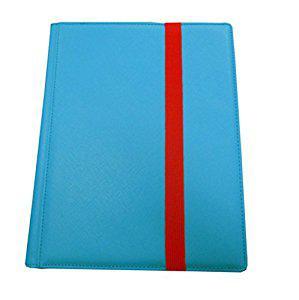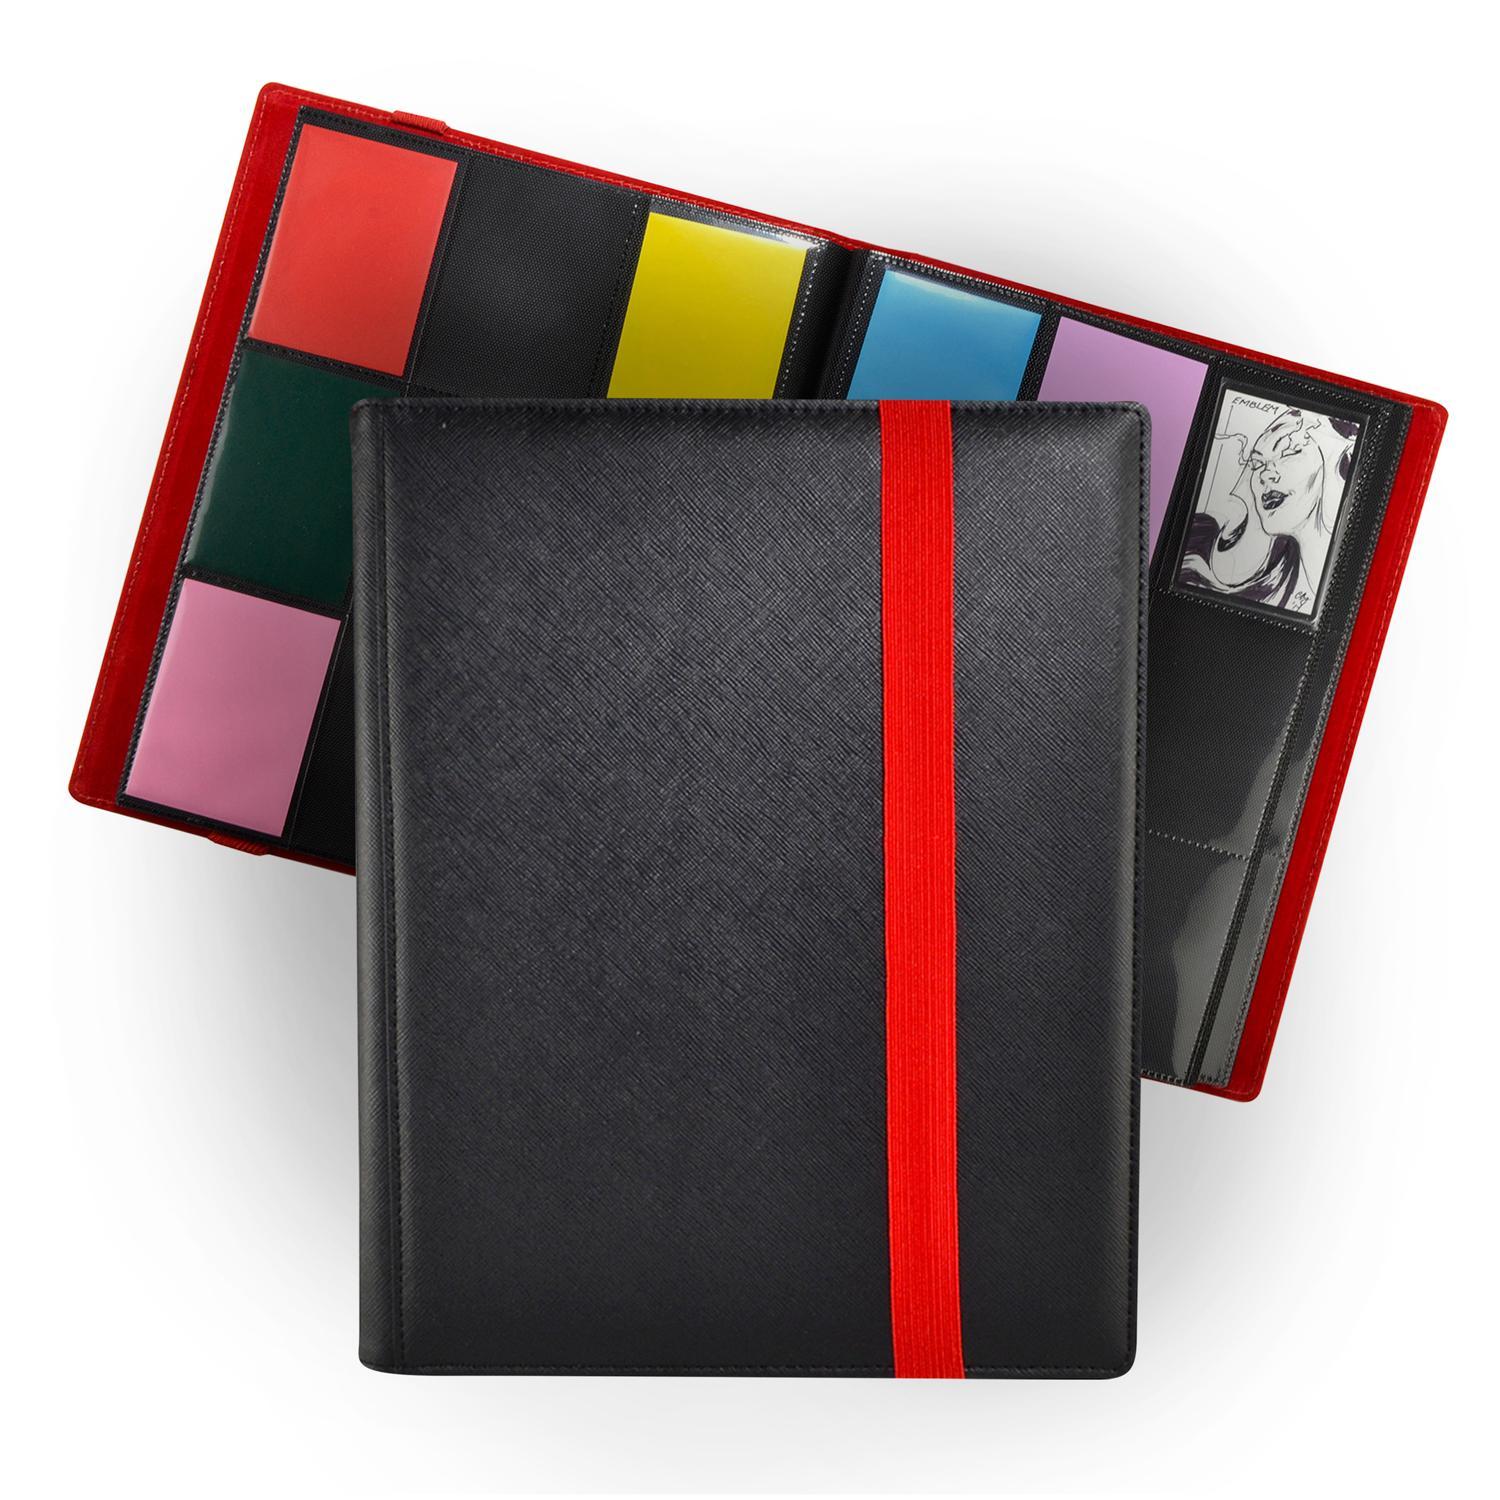The first image is the image on the left, the second image is the image on the right. Considering the images on both sides, is "An image depicts a purple binder next to an open binder." valid? Answer yes or no. No. 